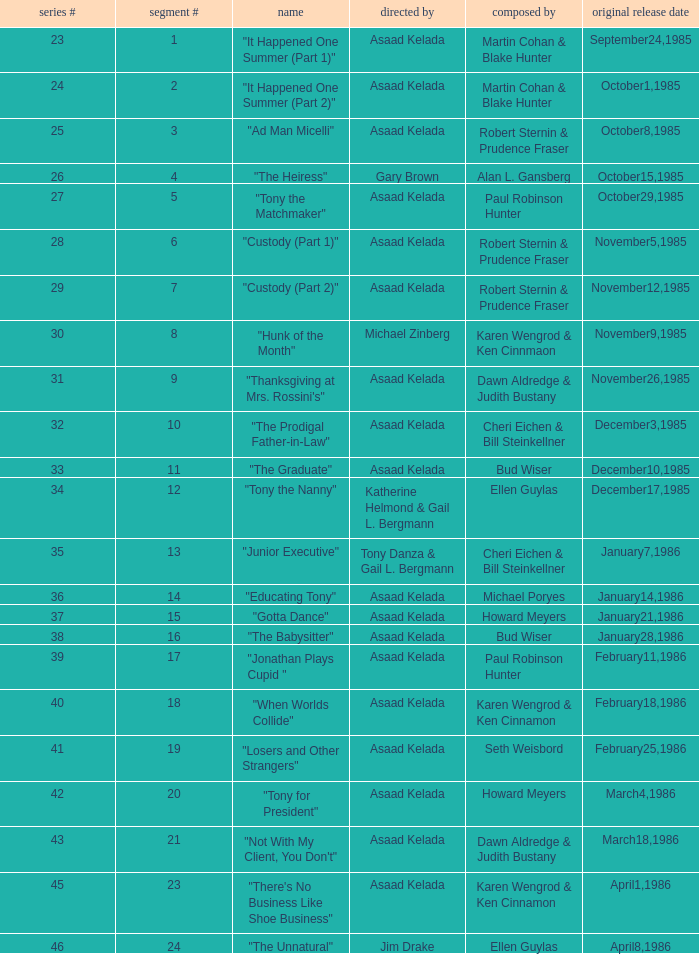What is the season where the episode "when worlds collide" was shown? 18.0. 